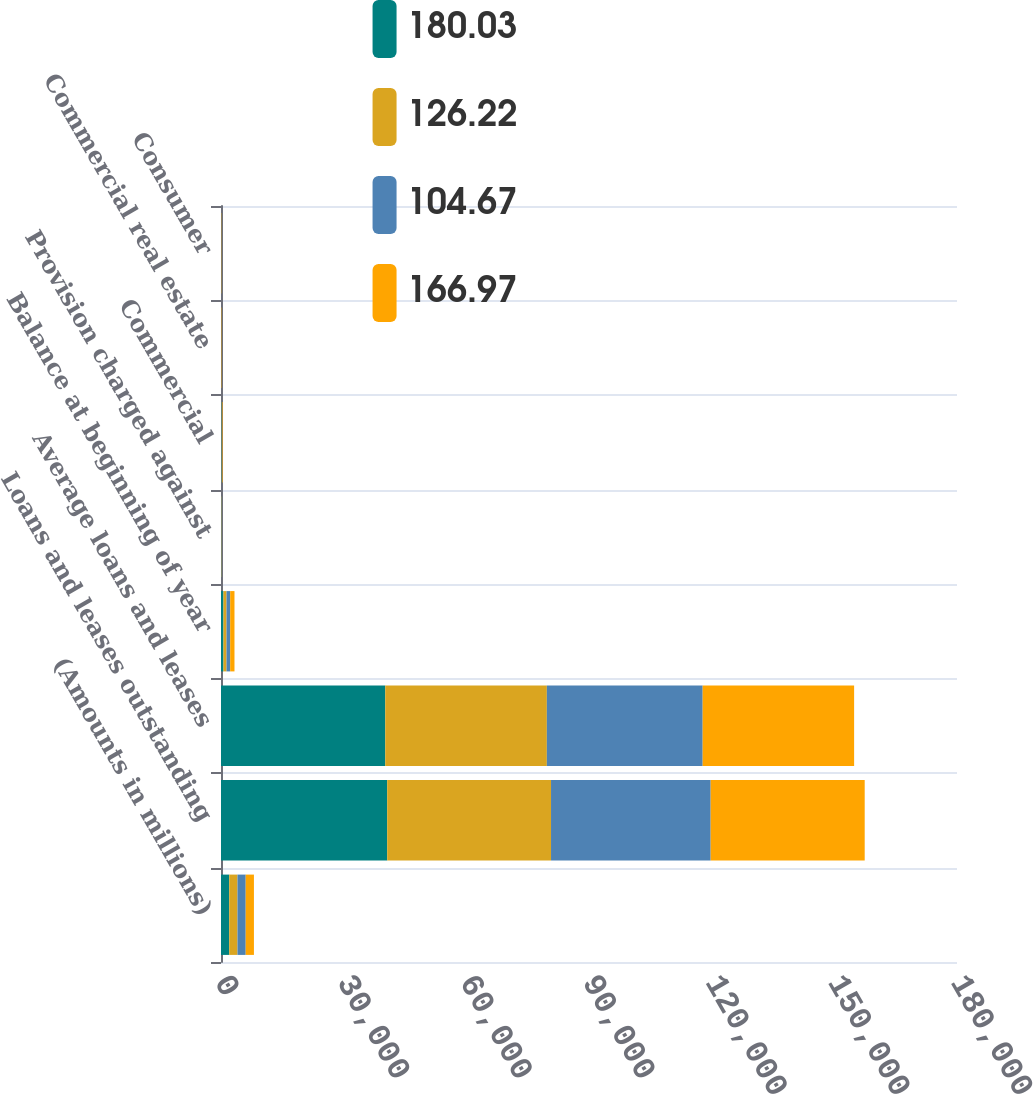Convert chart. <chart><loc_0><loc_0><loc_500><loc_500><stacked_bar_chart><ecel><fcel>(Amounts in millions)<fcel>Loans and leases outstanding<fcel>Average loans and leases<fcel>Balance at beginning of year<fcel>Provision charged against<fcel>Commercial<fcel>Commercial real estate<fcel>Consumer<nl><fcel>180.03<fcel>2015<fcel>40650<fcel>40171<fcel>605<fcel>40<fcel>111<fcel>14<fcel>14<nl><fcel>126.22<fcel>2014<fcel>40064<fcel>39522<fcel>746<fcel>98<fcel>77<fcel>15<fcel>14<nl><fcel>104.67<fcel>2013<fcel>39043<fcel>38109<fcel>896<fcel>87<fcel>76<fcel>26<fcel>29<nl><fcel>166.97<fcel>2012<fcel>37670<fcel>37037<fcel>1052<fcel>14<fcel>121<fcel>85<fcel>61<nl></chart> 